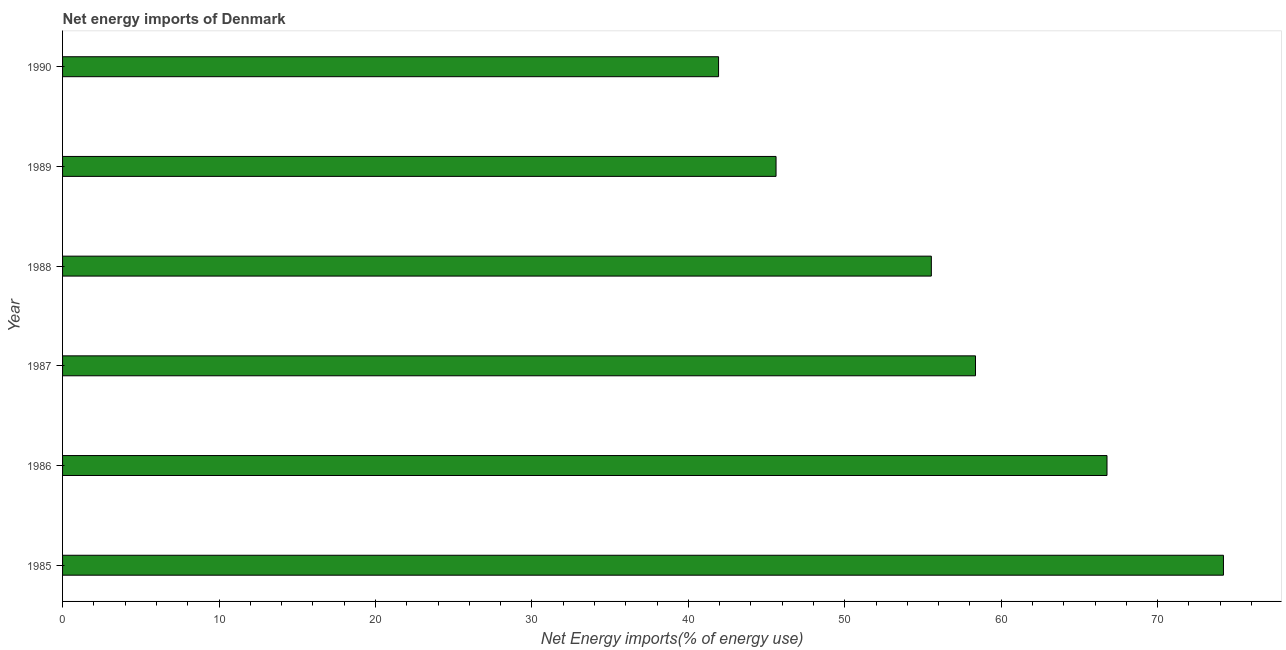Does the graph contain any zero values?
Offer a very short reply. No. What is the title of the graph?
Offer a very short reply. Net energy imports of Denmark. What is the label or title of the X-axis?
Your response must be concise. Net Energy imports(% of energy use). What is the label or title of the Y-axis?
Your answer should be very brief. Year. What is the energy imports in 1985?
Offer a very short reply. 74.2. Across all years, what is the maximum energy imports?
Your answer should be compact. 74.2. Across all years, what is the minimum energy imports?
Provide a succinct answer. 41.93. What is the sum of the energy imports?
Offer a very short reply. 342.39. What is the difference between the energy imports in 1988 and 1989?
Your answer should be very brief. 9.93. What is the average energy imports per year?
Offer a terse response. 57.06. What is the median energy imports?
Your answer should be very brief. 56.94. In how many years, is the energy imports greater than 10 %?
Your answer should be compact. 6. What is the ratio of the energy imports in 1988 to that in 1989?
Make the answer very short. 1.22. Is the difference between the energy imports in 1988 and 1990 greater than the difference between any two years?
Ensure brevity in your answer.  No. What is the difference between the highest and the second highest energy imports?
Give a very brief answer. 7.44. Is the sum of the energy imports in 1988 and 1990 greater than the maximum energy imports across all years?
Your response must be concise. Yes. What is the difference between the highest and the lowest energy imports?
Make the answer very short. 32.27. In how many years, is the energy imports greater than the average energy imports taken over all years?
Provide a succinct answer. 3. How many bars are there?
Keep it short and to the point. 6. What is the difference between two consecutive major ticks on the X-axis?
Offer a very short reply. 10. Are the values on the major ticks of X-axis written in scientific E-notation?
Make the answer very short. No. What is the Net Energy imports(% of energy use) in 1985?
Your answer should be very brief. 74.2. What is the Net Energy imports(% of energy use) of 1986?
Provide a short and direct response. 66.76. What is the Net Energy imports(% of energy use) in 1987?
Offer a very short reply. 58.35. What is the Net Energy imports(% of energy use) of 1988?
Provide a succinct answer. 55.53. What is the Net Energy imports(% of energy use) in 1989?
Provide a succinct answer. 45.61. What is the Net Energy imports(% of energy use) of 1990?
Ensure brevity in your answer.  41.93. What is the difference between the Net Energy imports(% of energy use) in 1985 and 1986?
Provide a short and direct response. 7.44. What is the difference between the Net Energy imports(% of energy use) in 1985 and 1987?
Provide a succinct answer. 15.85. What is the difference between the Net Energy imports(% of energy use) in 1985 and 1988?
Provide a succinct answer. 18.67. What is the difference between the Net Energy imports(% of energy use) in 1985 and 1989?
Your response must be concise. 28.6. What is the difference between the Net Energy imports(% of energy use) in 1985 and 1990?
Keep it short and to the point. 32.27. What is the difference between the Net Energy imports(% of energy use) in 1986 and 1987?
Keep it short and to the point. 8.41. What is the difference between the Net Energy imports(% of energy use) in 1986 and 1988?
Provide a succinct answer. 11.23. What is the difference between the Net Energy imports(% of energy use) in 1986 and 1989?
Offer a terse response. 21.15. What is the difference between the Net Energy imports(% of energy use) in 1986 and 1990?
Your response must be concise. 24.83. What is the difference between the Net Energy imports(% of energy use) in 1987 and 1988?
Keep it short and to the point. 2.82. What is the difference between the Net Energy imports(% of energy use) in 1987 and 1989?
Provide a succinct answer. 12.75. What is the difference between the Net Energy imports(% of energy use) in 1987 and 1990?
Give a very brief answer. 16.42. What is the difference between the Net Energy imports(% of energy use) in 1988 and 1989?
Your response must be concise. 9.93. What is the difference between the Net Energy imports(% of energy use) in 1988 and 1990?
Ensure brevity in your answer.  13.6. What is the difference between the Net Energy imports(% of energy use) in 1989 and 1990?
Provide a short and direct response. 3.67. What is the ratio of the Net Energy imports(% of energy use) in 1985 to that in 1986?
Your answer should be very brief. 1.11. What is the ratio of the Net Energy imports(% of energy use) in 1985 to that in 1987?
Make the answer very short. 1.27. What is the ratio of the Net Energy imports(% of energy use) in 1985 to that in 1988?
Give a very brief answer. 1.34. What is the ratio of the Net Energy imports(% of energy use) in 1985 to that in 1989?
Offer a terse response. 1.63. What is the ratio of the Net Energy imports(% of energy use) in 1985 to that in 1990?
Make the answer very short. 1.77. What is the ratio of the Net Energy imports(% of energy use) in 1986 to that in 1987?
Offer a terse response. 1.14. What is the ratio of the Net Energy imports(% of energy use) in 1986 to that in 1988?
Offer a very short reply. 1.2. What is the ratio of the Net Energy imports(% of energy use) in 1986 to that in 1989?
Provide a short and direct response. 1.46. What is the ratio of the Net Energy imports(% of energy use) in 1986 to that in 1990?
Provide a succinct answer. 1.59. What is the ratio of the Net Energy imports(% of energy use) in 1987 to that in 1988?
Make the answer very short. 1.05. What is the ratio of the Net Energy imports(% of energy use) in 1987 to that in 1989?
Your response must be concise. 1.28. What is the ratio of the Net Energy imports(% of energy use) in 1987 to that in 1990?
Your answer should be compact. 1.39. What is the ratio of the Net Energy imports(% of energy use) in 1988 to that in 1989?
Keep it short and to the point. 1.22. What is the ratio of the Net Energy imports(% of energy use) in 1988 to that in 1990?
Your response must be concise. 1.32. What is the ratio of the Net Energy imports(% of energy use) in 1989 to that in 1990?
Your answer should be compact. 1.09. 